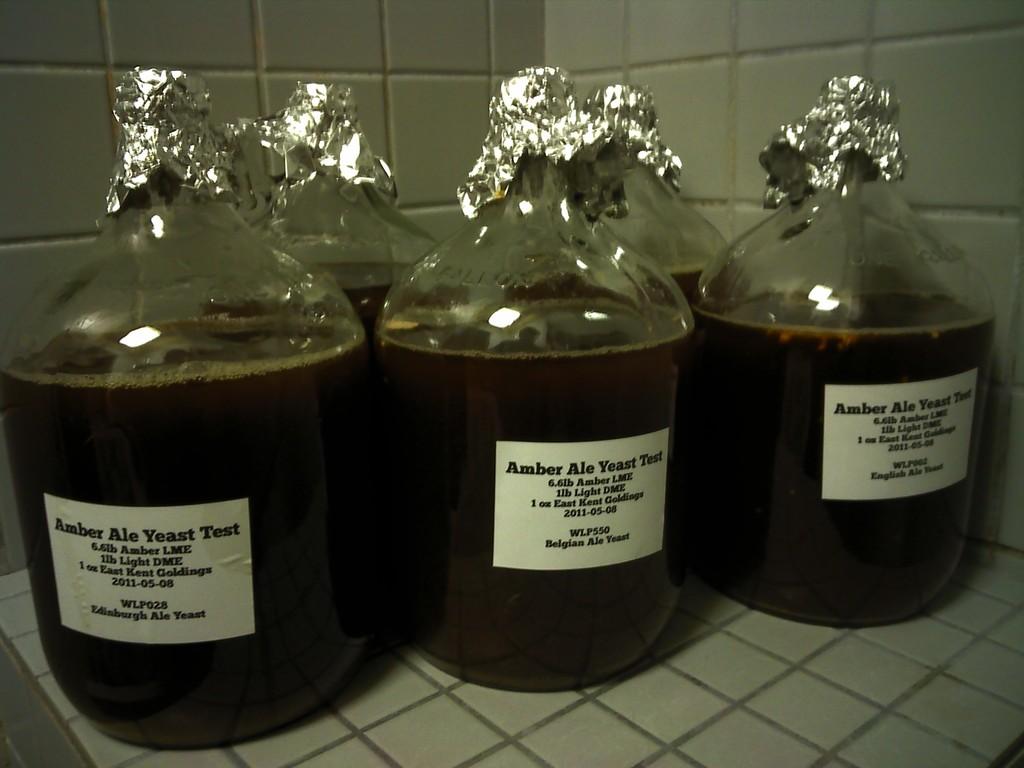What kind of test is this?
Your answer should be compact. Amber ale yeast. 